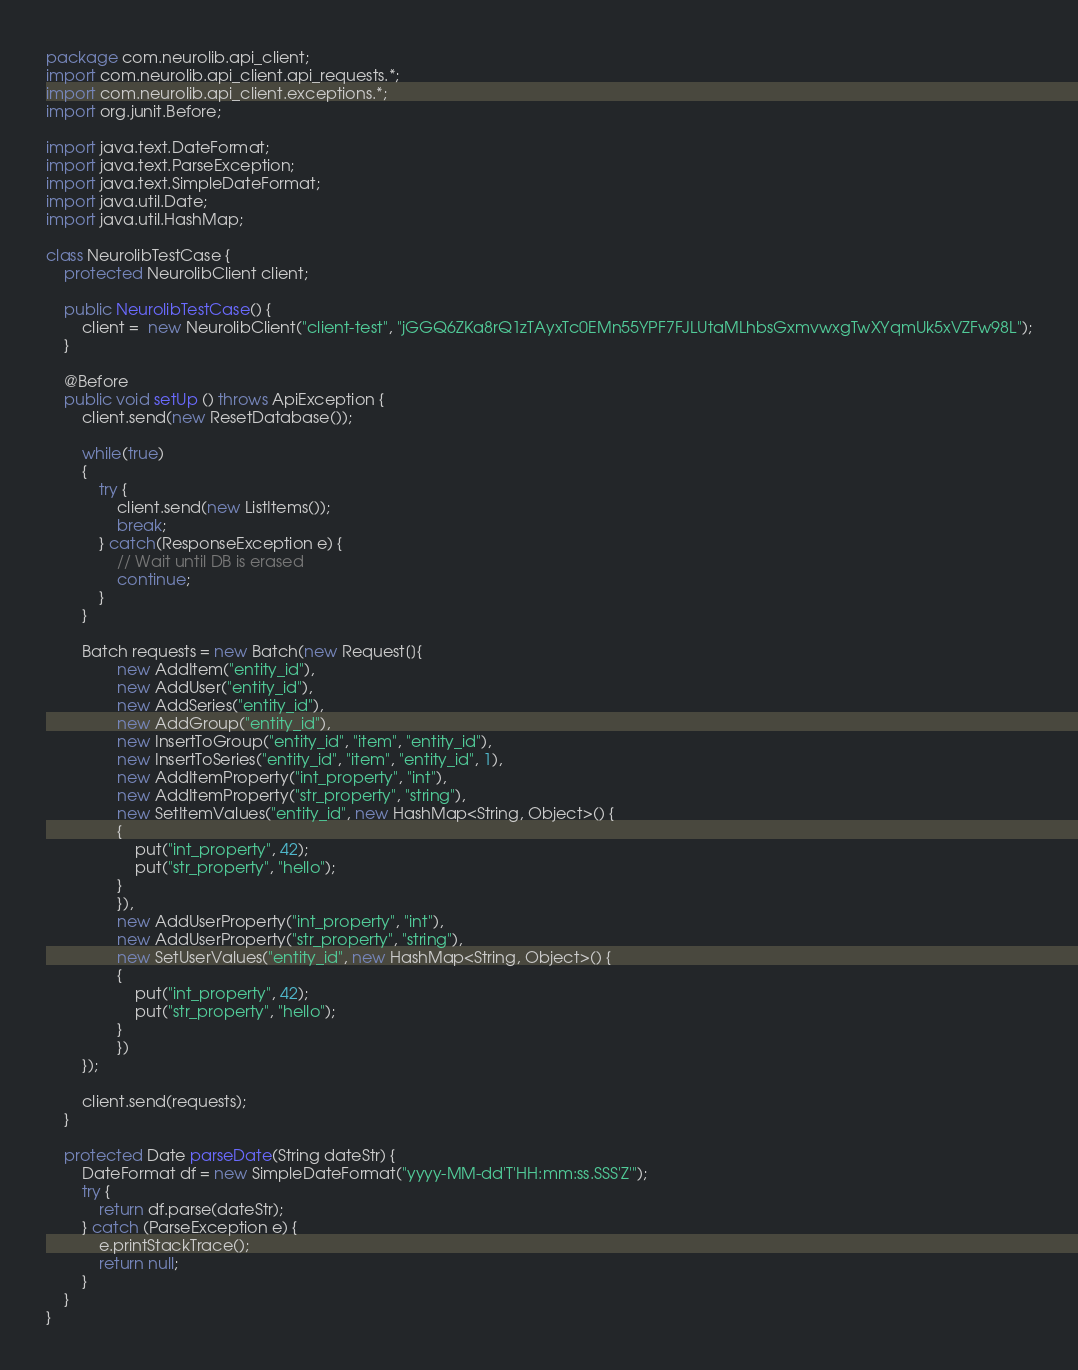<code> <loc_0><loc_0><loc_500><loc_500><_Java_>package com.neurolib.api_client;
import com.neurolib.api_client.api_requests.*;
import com.neurolib.api_client.exceptions.*;
import org.junit.Before;

import java.text.DateFormat;
import java.text.ParseException;
import java.text.SimpleDateFormat;
import java.util.Date;
import java.util.HashMap;

class NeurolibTestCase {
    protected NeurolibClient client;

    public NeurolibTestCase() {
        client =  new NeurolibClient("client-test", "jGGQ6ZKa8rQ1zTAyxTc0EMn55YPF7FJLUtaMLhbsGxmvwxgTwXYqmUk5xVZFw98L");
    }

    @Before
    public void setUp () throws ApiException {
        client.send(new ResetDatabase());

        while(true)
        {
            try {
                client.send(new ListItems());
                break;
            } catch(ResponseException e) {
                // Wait until DB is erased
                continue;
            }
        }

        Batch requests = new Batch(new Request[]{
                new AddItem("entity_id"),
                new AddUser("entity_id"),
                new AddSeries("entity_id"),
                new AddGroup("entity_id"),
                new InsertToGroup("entity_id", "item", "entity_id"),
                new InsertToSeries("entity_id", "item", "entity_id", 1),
                new AddItemProperty("int_property", "int"),
                new AddItemProperty("str_property", "string"),
                new SetItemValues("entity_id", new HashMap<String, Object>() {
                {
                    put("int_property", 42);
                    put("str_property", "hello");
                }
                }),
                new AddUserProperty("int_property", "int"),
                new AddUserProperty("str_property", "string"),
                new SetUserValues("entity_id", new HashMap<String, Object>() {
                {
                    put("int_property", 42);
                    put("str_property", "hello");
                }
                })
        });

        client.send(requests);
    }

    protected Date parseDate(String dateStr) {
        DateFormat df = new SimpleDateFormat("yyyy-MM-dd'T'HH:mm:ss.SSS'Z'");
        try {
            return df.parse(dateStr);
        } catch (ParseException e) {
            e.printStackTrace();
            return null;
        }
    }
}</code> 